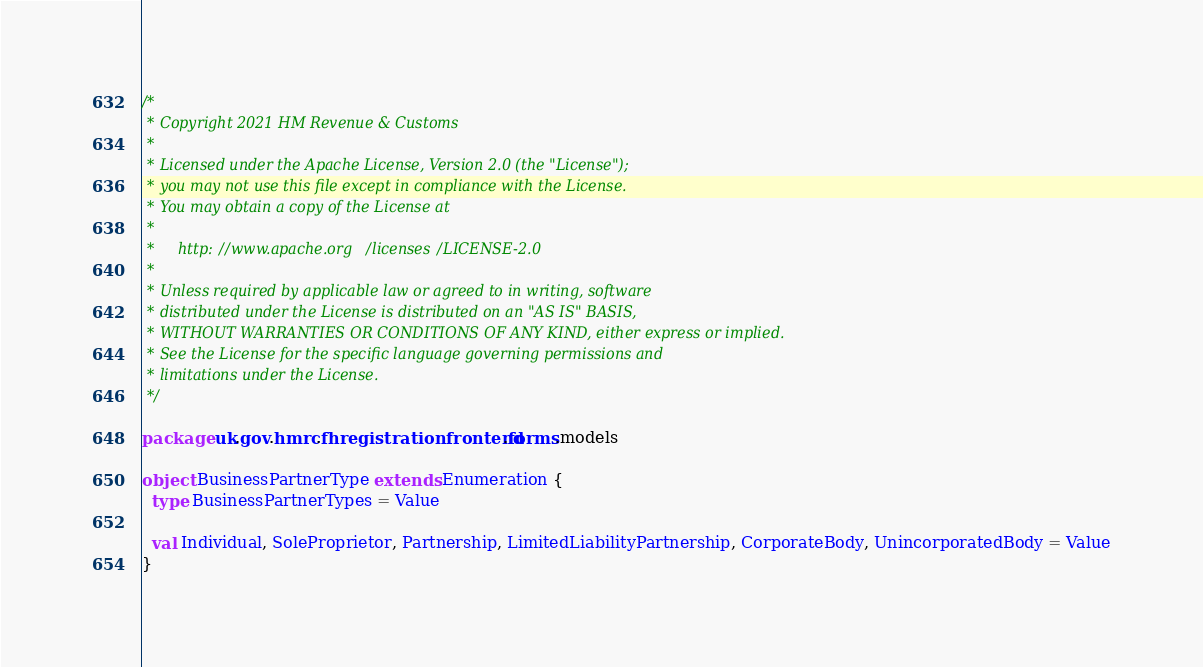<code> <loc_0><loc_0><loc_500><loc_500><_Scala_>/*
 * Copyright 2021 HM Revenue & Customs
 *
 * Licensed under the Apache License, Version 2.0 (the "License");
 * you may not use this file except in compliance with the License.
 * You may obtain a copy of the License at
 *
 *     http://www.apache.org/licenses/LICENSE-2.0
 *
 * Unless required by applicable law or agreed to in writing, software
 * distributed under the License is distributed on an "AS IS" BASIS,
 * WITHOUT WARRANTIES OR CONDITIONS OF ANY KIND, either express or implied.
 * See the License for the specific language governing permissions and
 * limitations under the License.
 */

package uk.gov.hmrc.fhregistrationfrontend.forms.models

object BusinessPartnerType extends Enumeration {
  type BusinessPartnerTypes = Value

  val Individual, SoleProprietor, Partnership, LimitedLiabilityPartnership, CorporateBody, UnincorporatedBody = Value
}
</code> 